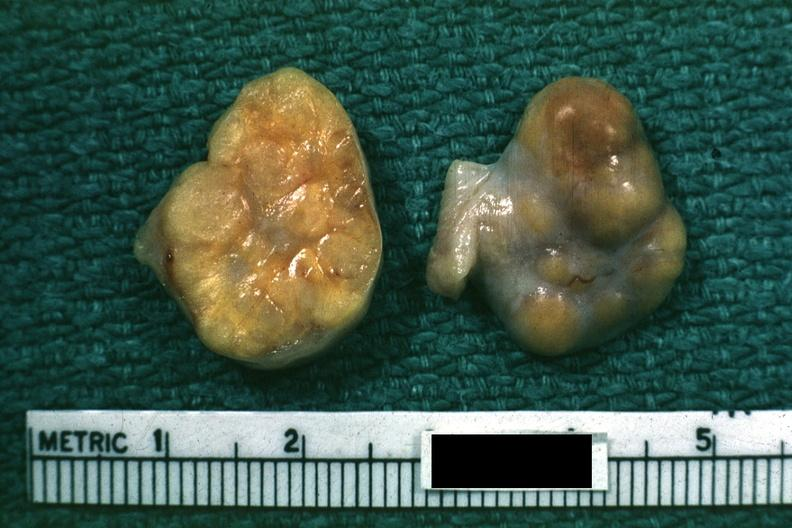does leiomyomas indicate theca cells can not recognize as ovary?
Answer the question using a single word or phrase. No 